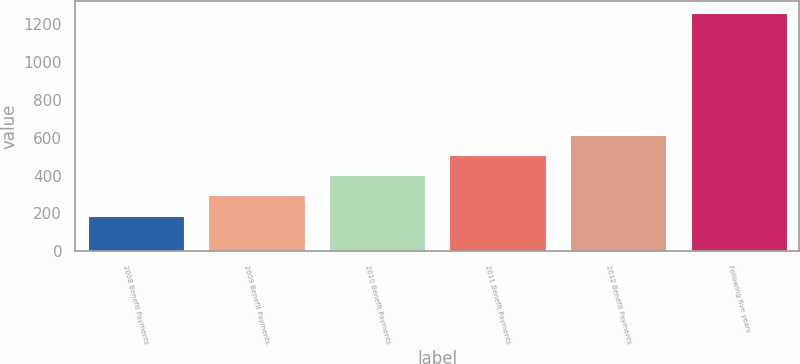<chart> <loc_0><loc_0><loc_500><loc_500><bar_chart><fcel>2008 Benefit Payments<fcel>2009 Benefit Payments<fcel>2010 Benefit Payments<fcel>2011 Benefit Payments<fcel>2012 Benefit Payments<fcel>Following five years<nl><fcel>188<fcel>295.1<fcel>402.2<fcel>509.3<fcel>616.4<fcel>1259<nl></chart> 